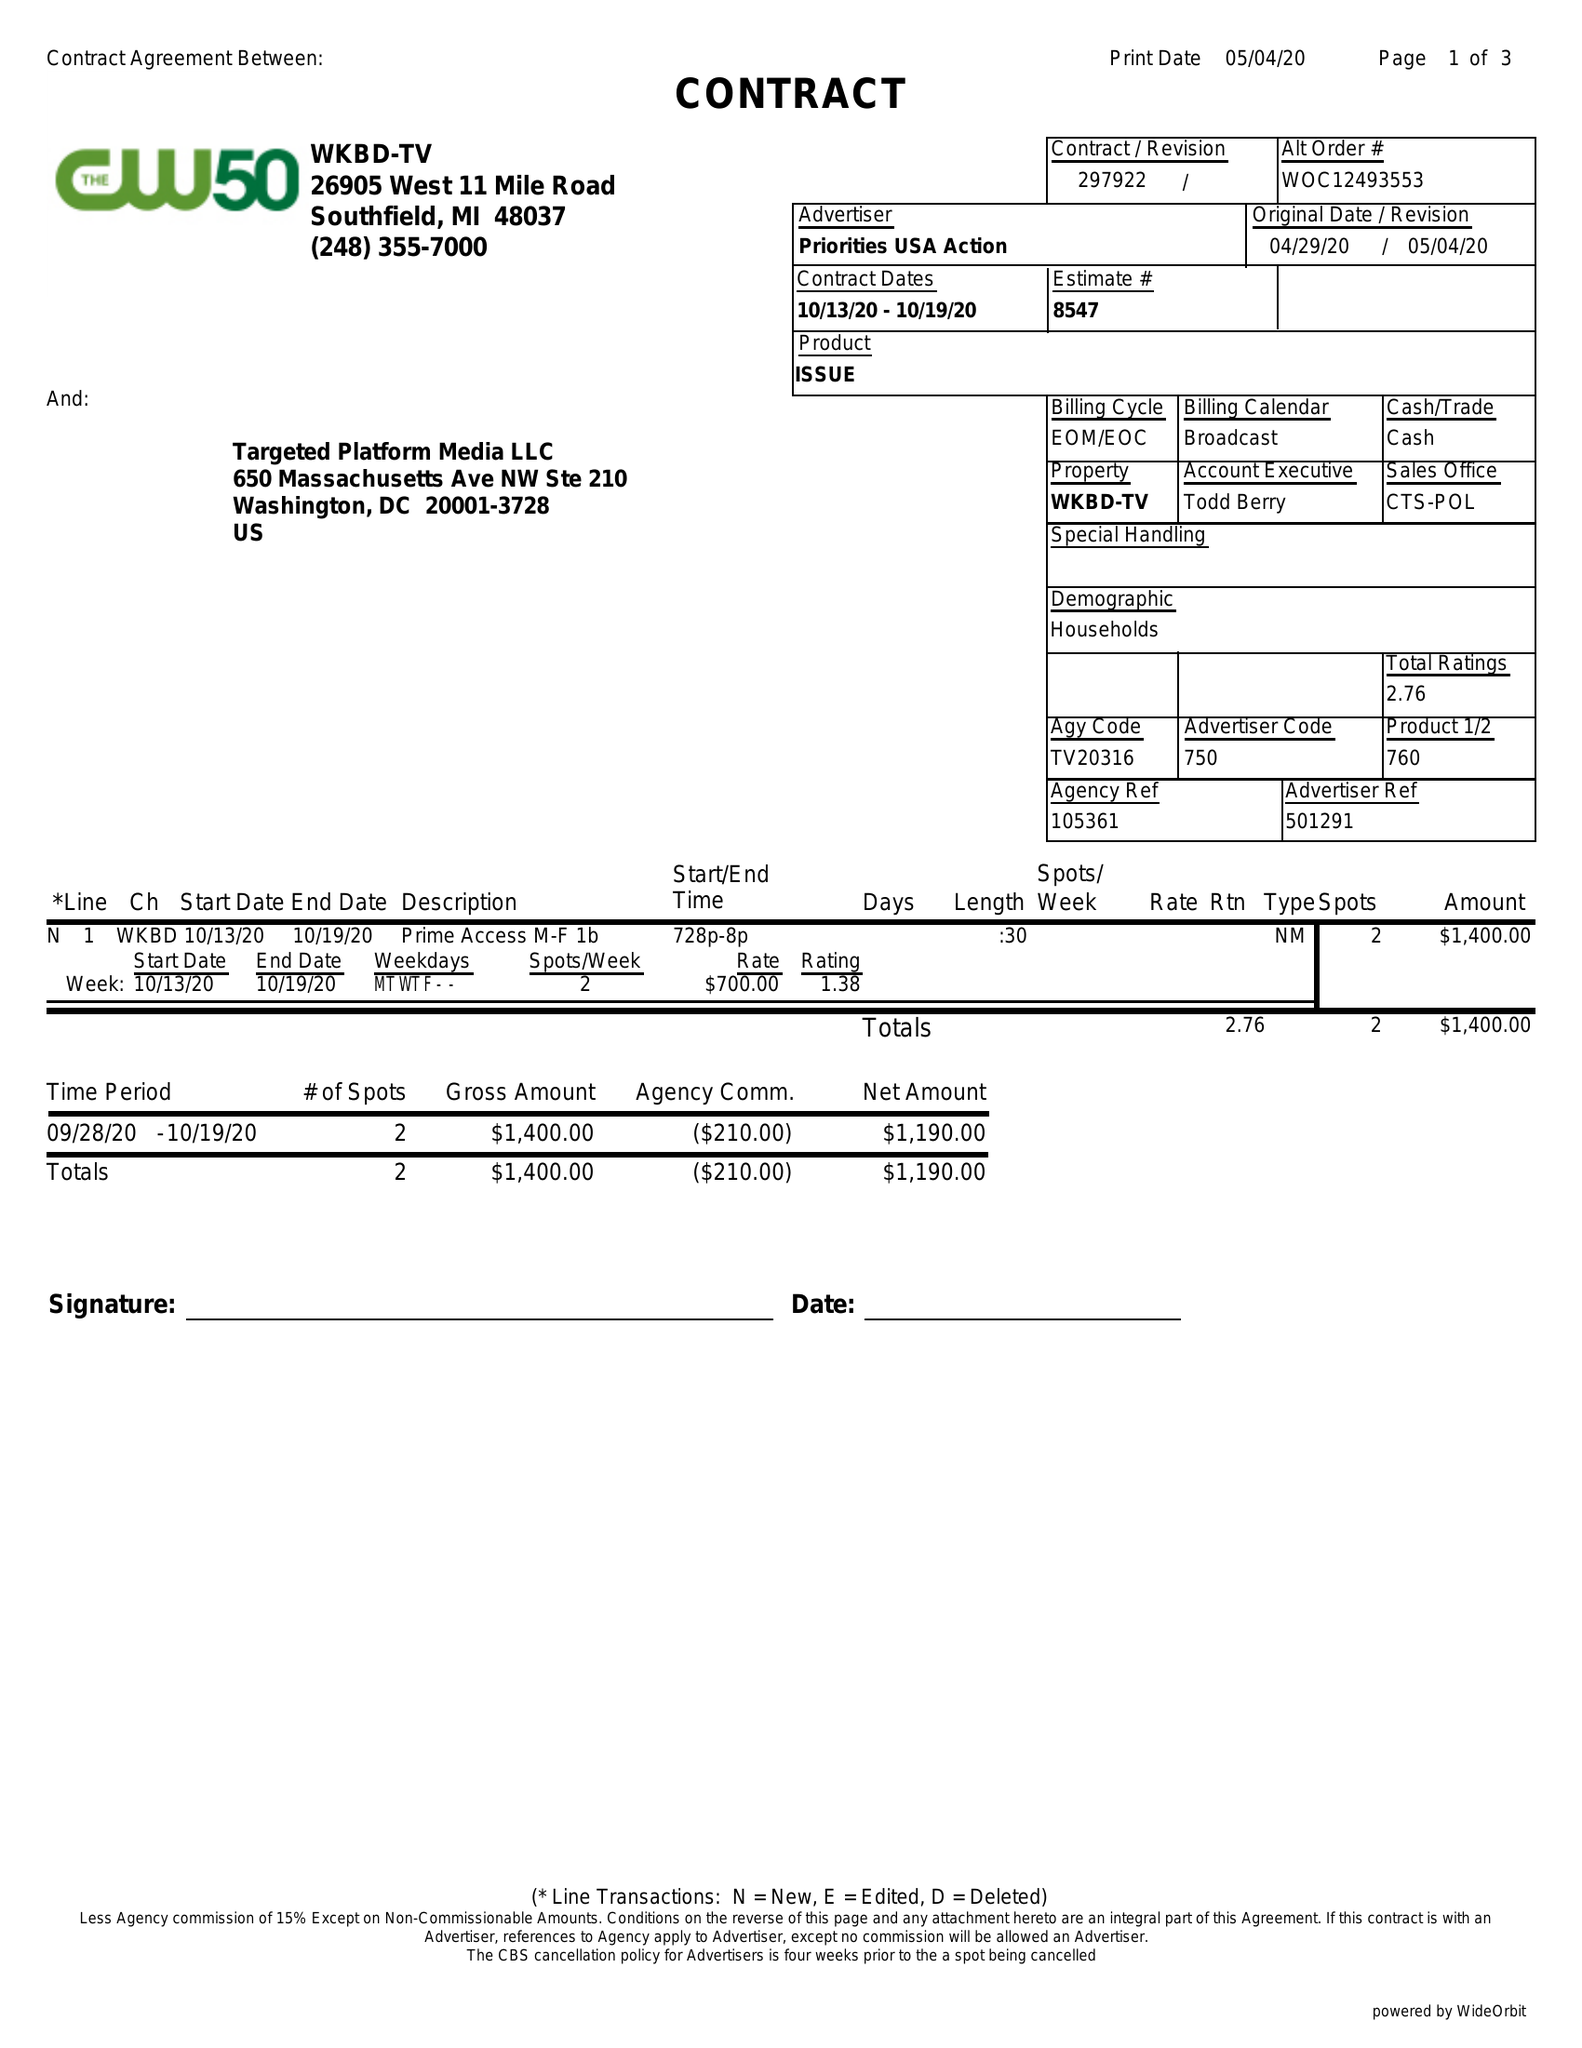What is the value for the contract_num?
Answer the question using a single word or phrase. 297922 